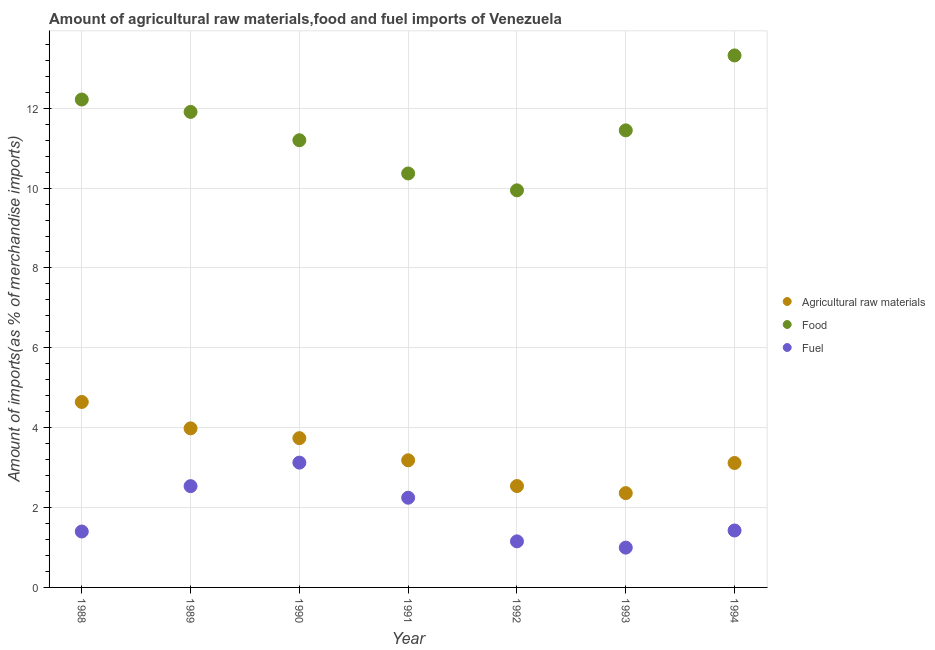How many different coloured dotlines are there?
Keep it short and to the point. 3. What is the percentage of food imports in 1993?
Your answer should be very brief. 11.45. Across all years, what is the maximum percentage of raw materials imports?
Ensure brevity in your answer.  4.64. Across all years, what is the minimum percentage of raw materials imports?
Ensure brevity in your answer.  2.36. In which year was the percentage of fuel imports minimum?
Make the answer very short. 1993. What is the total percentage of raw materials imports in the graph?
Your answer should be compact. 23.57. What is the difference between the percentage of food imports in 1991 and that in 1994?
Ensure brevity in your answer.  -2.96. What is the difference between the percentage of food imports in 1988 and the percentage of fuel imports in 1993?
Provide a short and direct response. 11.22. What is the average percentage of fuel imports per year?
Your answer should be compact. 1.84. In the year 1990, what is the difference between the percentage of fuel imports and percentage of food imports?
Your answer should be compact. -8.07. What is the ratio of the percentage of fuel imports in 1990 to that in 1991?
Provide a short and direct response. 1.39. Is the percentage of raw materials imports in 1989 less than that in 1992?
Keep it short and to the point. No. Is the difference between the percentage of fuel imports in 1991 and 1994 greater than the difference between the percentage of food imports in 1991 and 1994?
Provide a short and direct response. Yes. What is the difference between the highest and the second highest percentage of food imports?
Provide a succinct answer. 1.1. What is the difference between the highest and the lowest percentage of raw materials imports?
Your answer should be very brief. 2.28. Is the sum of the percentage of fuel imports in 1988 and 1992 greater than the maximum percentage of raw materials imports across all years?
Ensure brevity in your answer.  No. Is it the case that in every year, the sum of the percentage of raw materials imports and percentage of food imports is greater than the percentage of fuel imports?
Your answer should be very brief. Yes. Does the percentage of food imports monotonically increase over the years?
Provide a short and direct response. No. Is the percentage of food imports strictly less than the percentage of fuel imports over the years?
Provide a short and direct response. No. How many dotlines are there?
Your answer should be very brief. 3. How many years are there in the graph?
Keep it short and to the point. 7. What is the difference between two consecutive major ticks on the Y-axis?
Keep it short and to the point. 2. Does the graph contain any zero values?
Give a very brief answer. No. Where does the legend appear in the graph?
Your answer should be very brief. Center right. How are the legend labels stacked?
Provide a succinct answer. Vertical. What is the title of the graph?
Your answer should be compact. Amount of agricultural raw materials,food and fuel imports of Venezuela. What is the label or title of the Y-axis?
Your answer should be very brief. Amount of imports(as % of merchandise imports). What is the Amount of imports(as % of merchandise imports) in Agricultural raw materials in 1988?
Keep it short and to the point. 4.64. What is the Amount of imports(as % of merchandise imports) in Food in 1988?
Your answer should be very brief. 12.22. What is the Amount of imports(as % of merchandise imports) of Fuel in 1988?
Make the answer very short. 1.4. What is the Amount of imports(as % of merchandise imports) of Agricultural raw materials in 1989?
Your answer should be very brief. 3.98. What is the Amount of imports(as % of merchandise imports) in Food in 1989?
Your answer should be compact. 11.91. What is the Amount of imports(as % of merchandise imports) of Fuel in 1989?
Make the answer very short. 2.54. What is the Amount of imports(as % of merchandise imports) in Agricultural raw materials in 1990?
Provide a succinct answer. 3.74. What is the Amount of imports(as % of merchandise imports) of Food in 1990?
Make the answer very short. 11.2. What is the Amount of imports(as % of merchandise imports) of Fuel in 1990?
Your response must be concise. 3.13. What is the Amount of imports(as % of merchandise imports) in Agricultural raw materials in 1991?
Provide a succinct answer. 3.18. What is the Amount of imports(as % of merchandise imports) of Food in 1991?
Make the answer very short. 10.37. What is the Amount of imports(as % of merchandise imports) in Fuel in 1991?
Make the answer very short. 2.25. What is the Amount of imports(as % of merchandise imports) in Agricultural raw materials in 1992?
Make the answer very short. 2.54. What is the Amount of imports(as % of merchandise imports) in Food in 1992?
Your answer should be compact. 9.94. What is the Amount of imports(as % of merchandise imports) in Fuel in 1992?
Provide a succinct answer. 1.15. What is the Amount of imports(as % of merchandise imports) of Agricultural raw materials in 1993?
Keep it short and to the point. 2.36. What is the Amount of imports(as % of merchandise imports) in Food in 1993?
Provide a succinct answer. 11.45. What is the Amount of imports(as % of merchandise imports) in Fuel in 1993?
Make the answer very short. 1. What is the Amount of imports(as % of merchandise imports) in Agricultural raw materials in 1994?
Give a very brief answer. 3.12. What is the Amount of imports(as % of merchandise imports) of Food in 1994?
Provide a short and direct response. 13.32. What is the Amount of imports(as % of merchandise imports) of Fuel in 1994?
Ensure brevity in your answer.  1.43. Across all years, what is the maximum Amount of imports(as % of merchandise imports) of Agricultural raw materials?
Ensure brevity in your answer.  4.64. Across all years, what is the maximum Amount of imports(as % of merchandise imports) of Food?
Your answer should be very brief. 13.32. Across all years, what is the maximum Amount of imports(as % of merchandise imports) in Fuel?
Provide a succinct answer. 3.13. Across all years, what is the minimum Amount of imports(as % of merchandise imports) of Agricultural raw materials?
Make the answer very short. 2.36. Across all years, what is the minimum Amount of imports(as % of merchandise imports) of Food?
Provide a short and direct response. 9.94. Across all years, what is the minimum Amount of imports(as % of merchandise imports) of Fuel?
Provide a short and direct response. 1. What is the total Amount of imports(as % of merchandise imports) in Agricultural raw materials in the graph?
Make the answer very short. 23.57. What is the total Amount of imports(as % of merchandise imports) in Food in the graph?
Provide a succinct answer. 80.4. What is the total Amount of imports(as % of merchandise imports) in Fuel in the graph?
Your answer should be very brief. 12.88. What is the difference between the Amount of imports(as % of merchandise imports) in Agricultural raw materials in 1988 and that in 1989?
Make the answer very short. 0.66. What is the difference between the Amount of imports(as % of merchandise imports) in Food in 1988 and that in 1989?
Offer a very short reply. 0.31. What is the difference between the Amount of imports(as % of merchandise imports) in Fuel in 1988 and that in 1989?
Ensure brevity in your answer.  -1.14. What is the difference between the Amount of imports(as % of merchandise imports) of Agricultural raw materials in 1988 and that in 1990?
Provide a short and direct response. 0.91. What is the difference between the Amount of imports(as % of merchandise imports) in Food in 1988 and that in 1990?
Your answer should be compact. 1.02. What is the difference between the Amount of imports(as % of merchandise imports) of Fuel in 1988 and that in 1990?
Keep it short and to the point. -1.72. What is the difference between the Amount of imports(as % of merchandise imports) in Agricultural raw materials in 1988 and that in 1991?
Your answer should be compact. 1.46. What is the difference between the Amount of imports(as % of merchandise imports) of Food in 1988 and that in 1991?
Keep it short and to the point. 1.85. What is the difference between the Amount of imports(as % of merchandise imports) of Fuel in 1988 and that in 1991?
Your answer should be compact. -0.85. What is the difference between the Amount of imports(as % of merchandise imports) of Agricultural raw materials in 1988 and that in 1992?
Your response must be concise. 2.11. What is the difference between the Amount of imports(as % of merchandise imports) in Food in 1988 and that in 1992?
Offer a very short reply. 2.27. What is the difference between the Amount of imports(as % of merchandise imports) in Fuel in 1988 and that in 1992?
Provide a succinct answer. 0.25. What is the difference between the Amount of imports(as % of merchandise imports) in Agricultural raw materials in 1988 and that in 1993?
Offer a terse response. 2.28. What is the difference between the Amount of imports(as % of merchandise imports) of Food in 1988 and that in 1993?
Your answer should be very brief. 0.77. What is the difference between the Amount of imports(as % of merchandise imports) in Fuel in 1988 and that in 1993?
Make the answer very short. 0.4. What is the difference between the Amount of imports(as % of merchandise imports) in Agricultural raw materials in 1988 and that in 1994?
Provide a succinct answer. 1.53. What is the difference between the Amount of imports(as % of merchandise imports) in Food in 1988 and that in 1994?
Keep it short and to the point. -1.1. What is the difference between the Amount of imports(as % of merchandise imports) of Fuel in 1988 and that in 1994?
Keep it short and to the point. -0.03. What is the difference between the Amount of imports(as % of merchandise imports) in Agricultural raw materials in 1989 and that in 1990?
Your response must be concise. 0.25. What is the difference between the Amount of imports(as % of merchandise imports) in Food in 1989 and that in 1990?
Your answer should be compact. 0.71. What is the difference between the Amount of imports(as % of merchandise imports) of Fuel in 1989 and that in 1990?
Keep it short and to the point. -0.59. What is the difference between the Amount of imports(as % of merchandise imports) of Agricultural raw materials in 1989 and that in 1991?
Your answer should be very brief. 0.8. What is the difference between the Amount of imports(as % of merchandise imports) of Food in 1989 and that in 1991?
Your answer should be compact. 1.54. What is the difference between the Amount of imports(as % of merchandise imports) of Fuel in 1989 and that in 1991?
Make the answer very short. 0.29. What is the difference between the Amount of imports(as % of merchandise imports) in Agricultural raw materials in 1989 and that in 1992?
Offer a very short reply. 1.45. What is the difference between the Amount of imports(as % of merchandise imports) of Food in 1989 and that in 1992?
Your answer should be compact. 1.96. What is the difference between the Amount of imports(as % of merchandise imports) of Fuel in 1989 and that in 1992?
Your response must be concise. 1.38. What is the difference between the Amount of imports(as % of merchandise imports) in Agricultural raw materials in 1989 and that in 1993?
Offer a terse response. 1.62. What is the difference between the Amount of imports(as % of merchandise imports) of Food in 1989 and that in 1993?
Your answer should be compact. 0.46. What is the difference between the Amount of imports(as % of merchandise imports) of Fuel in 1989 and that in 1993?
Your answer should be compact. 1.54. What is the difference between the Amount of imports(as % of merchandise imports) in Agricultural raw materials in 1989 and that in 1994?
Offer a very short reply. 0.87. What is the difference between the Amount of imports(as % of merchandise imports) of Food in 1989 and that in 1994?
Provide a short and direct response. -1.41. What is the difference between the Amount of imports(as % of merchandise imports) in Fuel in 1989 and that in 1994?
Make the answer very short. 1.11. What is the difference between the Amount of imports(as % of merchandise imports) in Agricultural raw materials in 1990 and that in 1991?
Your response must be concise. 0.55. What is the difference between the Amount of imports(as % of merchandise imports) in Food in 1990 and that in 1991?
Your answer should be compact. 0.83. What is the difference between the Amount of imports(as % of merchandise imports) of Fuel in 1990 and that in 1991?
Offer a very short reply. 0.88. What is the difference between the Amount of imports(as % of merchandise imports) in Agricultural raw materials in 1990 and that in 1992?
Provide a succinct answer. 1.2. What is the difference between the Amount of imports(as % of merchandise imports) in Food in 1990 and that in 1992?
Your answer should be very brief. 1.25. What is the difference between the Amount of imports(as % of merchandise imports) in Fuel in 1990 and that in 1992?
Your answer should be compact. 1.97. What is the difference between the Amount of imports(as % of merchandise imports) of Agricultural raw materials in 1990 and that in 1993?
Make the answer very short. 1.38. What is the difference between the Amount of imports(as % of merchandise imports) in Food in 1990 and that in 1993?
Make the answer very short. -0.25. What is the difference between the Amount of imports(as % of merchandise imports) of Fuel in 1990 and that in 1993?
Offer a terse response. 2.13. What is the difference between the Amount of imports(as % of merchandise imports) in Agricultural raw materials in 1990 and that in 1994?
Your answer should be compact. 0.62. What is the difference between the Amount of imports(as % of merchandise imports) of Food in 1990 and that in 1994?
Make the answer very short. -2.12. What is the difference between the Amount of imports(as % of merchandise imports) in Fuel in 1990 and that in 1994?
Offer a very short reply. 1.7. What is the difference between the Amount of imports(as % of merchandise imports) of Agricultural raw materials in 1991 and that in 1992?
Ensure brevity in your answer.  0.65. What is the difference between the Amount of imports(as % of merchandise imports) of Food in 1991 and that in 1992?
Provide a short and direct response. 0.42. What is the difference between the Amount of imports(as % of merchandise imports) of Fuel in 1991 and that in 1992?
Give a very brief answer. 1.09. What is the difference between the Amount of imports(as % of merchandise imports) in Agricultural raw materials in 1991 and that in 1993?
Give a very brief answer. 0.82. What is the difference between the Amount of imports(as % of merchandise imports) in Food in 1991 and that in 1993?
Make the answer very short. -1.08. What is the difference between the Amount of imports(as % of merchandise imports) in Fuel in 1991 and that in 1993?
Ensure brevity in your answer.  1.25. What is the difference between the Amount of imports(as % of merchandise imports) in Agricultural raw materials in 1991 and that in 1994?
Offer a terse response. 0.07. What is the difference between the Amount of imports(as % of merchandise imports) of Food in 1991 and that in 1994?
Your response must be concise. -2.96. What is the difference between the Amount of imports(as % of merchandise imports) in Fuel in 1991 and that in 1994?
Offer a terse response. 0.82. What is the difference between the Amount of imports(as % of merchandise imports) in Agricultural raw materials in 1992 and that in 1993?
Your response must be concise. 0.18. What is the difference between the Amount of imports(as % of merchandise imports) in Food in 1992 and that in 1993?
Offer a terse response. -1.5. What is the difference between the Amount of imports(as % of merchandise imports) of Fuel in 1992 and that in 1993?
Your answer should be compact. 0.16. What is the difference between the Amount of imports(as % of merchandise imports) in Agricultural raw materials in 1992 and that in 1994?
Make the answer very short. -0.58. What is the difference between the Amount of imports(as % of merchandise imports) of Food in 1992 and that in 1994?
Offer a very short reply. -3.38. What is the difference between the Amount of imports(as % of merchandise imports) in Fuel in 1992 and that in 1994?
Provide a short and direct response. -0.27. What is the difference between the Amount of imports(as % of merchandise imports) in Agricultural raw materials in 1993 and that in 1994?
Offer a terse response. -0.75. What is the difference between the Amount of imports(as % of merchandise imports) in Food in 1993 and that in 1994?
Provide a succinct answer. -1.88. What is the difference between the Amount of imports(as % of merchandise imports) in Fuel in 1993 and that in 1994?
Keep it short and to the point. -0.43. What is the difference between the Amount of imports(as % of merchandise imports) of Agricultural raw materials in 1988 and the Amount of imports(as % of merchandise imports) of Food in 1989?
Your answer should be compact. -7.26. What is the difference between the Amount of imports(as % of merchandise imports) in Agricultural raw materials in 1988 and the Amount of imports(as % of merchandise imports) in Fuel in 1989?
Give a very brief answer. 2.11. What is the difference between the Amount of imports(as % of merchandise imports) in Food in 1988 and the Amount of imports(as % of merchandise imports) in Fuel in 1989?
Offer a very short reply. 9.68. What is the difference between the Amount of imports(as % of merchandise imports) of Agricultural raw materials in 1988 and the Amount of imports(as % of merchandise imports) of Food in 1990?
Your answer should be compact. -6.55. What is the difference between the Amount of imports(as % of merchandise imports) of Agricultural raw materials in 1988 and the Amount of imports(as % of merchandise imports) of Fuel in 1990?
Give a very brief answer. 1.52. What is the difference between the Amount of imports(as % of merchandise imports) of Food in 1988 and the Amount of imports(as % of merchandise imports) of Fuel in 1990?
Make the answer very short. 9.09. What is the difference between the Amount of imports(as % of merchandise imports) of Agricultural raw materials in 1988 and the Amount of imports(as % of merchandise imports) of Food in 1991?
Your response must be concise. -5.72. What is the difference between the Amount of imports(as % of merchandise imports) of Agricultural raw materials in 1988 and the Amount of imports(as % of merchandise imports) of Fuel in 1991?
Make the answer very short. 2.4. What is the difference between the Amount of imports(as % of merchandise imports) of Food in 1988 and the Amount of imports(as % of merchandise imports) of Fuel in 1991?
Offer a very short reply. 9.97. What is the difference between the Amount of imports(as % of merchandise imports) of Agricultural raw materials in 1988 and the Amount of imports(as % of merchandise imports) of Fuel in 1992?
Give a very brief answer. 3.49. What is the difference between the Amount of imports(as % of merchandise imports) in Food in 1988 and the Amount of imports(as % of merchandise imports) in Fuel in 1992?
Offer a very short reply. 11.06. What is the difference between the Amount of imports(as % of merchandise imports) of Agricultural raw materials in 1988 and the Amount of imports(as % of merchandise imports) of Food in 1993?
Your answer should be compact. -6.8. What is the difference between the Amount of imports(as % of merchandise imports) in Agricultural raw materials in 1988 and the Amount of imports(as % of merchandise imports) in Fuel in 1993?
Your answer should be compact. 3.65. What is the difference between the Amount of imports(as % of merchandise imports) of Food in 1988 and the Amount of imports(as % of merchandise imports) of Fuel in 1993?
Provide a short and direct response. 11.22. What is the difference between the Amount of imports(as % of merchandise imports) of Agricultural raw materials in 1988 and the Amount of imports(as % of merchandise imports) of Food in 1994?
Offer a very short reply. -8.68. What is the difference between the Amount of imports(as % of merchandise imports) of Agricultural raw materials in 1988 and the Amount of imports(as % of merchandise imports) of Fuel in 1994?
Your response must be concise. 3.22. What is the difference between the Amount of imports(as % of merchandise imports) in Food in 1988 and the Amount of imports(as % of merchandise imports) in Fuel in 1994?
Give a very brief answer. 10.79. What is the difference between the Amount of imports(as % of merchandise imports) in Agricultural raw materials in 1989 and the Amount of imports(as % of merchandise imports) in Food in 1990?
Ensure brevity in your answer.  -7.21. What is the difference between the Amount of imports(as % of merchandise imports) of Agricultural raw materials in 1989 and the Amount of imports(as % of merchandise imports) of Fuel in 1990?
Your answer should be compact. 0.86. What is the difference between the Amount of imports(as % of merchandise imports) in Food in 1989 and the Amount of imports(as % of merchandise imports) in Fuel in 1990?
Give a very brief answer. 8.78. What is the difference between the Amount of imports(as % of merchandise imports) of Agricultural raw materials in 1989 and the Amount of imports(as % of merchandise imports) of Food in 1991?
Ensure brevity in your answer.  -6.38. What is the difference between the Amount of imports(as % of merchandise imports) in Agricultural raw materials in 1989 and the Amount of imports(as % of merchandise imports) in Fuel in 1991?
Provide a succinct answer. 1.74. What is the difference between the Amount of imports(as % of merchandise imports) of Food in 1989 and the Amount of imports(as % of merchandise imports) of Fuel in 1991?
Ensure brevity in your answer.  9.66. What is the difference between the Amount of imports(as % of merchandise imports) of Agricultural raw materials in 1989 and the Amount of imports(as % of merchandise imports) of Food in 1992?
Give a very brief answer. -5.96. What is the difference between the Amount of imports(as % of merchandise imports) in Agricultural raw materials in 1989 and the Amount of imports(as % of merchandise imports) in Fuel in 1992?
Ensure brevity in your answer.  2.83. What is the difference between the Amount of imports(as % of merchandise imports) in Food in 1989 and the Amount of imports(as % of merchandise imports) in Fuel in 1992?
Your answer should be compact. 10.75. What is the difference between the Amount of imports(as % of merchandise imports) of Agricultural raw materials in 1989 and the Amount of imports(as % of merchandise imports) of Food in 1993?
Make the answer very short. -7.46. What is the difference between the Amount of imports(as % of merchandise imports) in Agricultural raw materials in 1989 and the Amount of imports(as % of merchandise imports) in Fuel in 1993?
Provide a succinct answer. 2.99. What is the difference between the Amount of imports(as % of merchandise imports) in Food in 1989 and the Amount of imports(as % of merchandise imports) in Fuel in 1993?
Give a very brief answer. 10.91. What is the difference between the Amount of imports(as % of merchandise imports) of Agricultural raw materials in 1989 and the Amount of imports(as % of merchandise imports) of Food in 1994?
Keep it short and to the point. -9.34. What is the difference between the Amount of imports(as % of merchandise imports) in Agricultural raw materials in 1989 and the Amount of imports(as % of merchandise imports) in Fuel in 1994?
Give a very brief answer. 2.56. What is the difference between the Amount of imports(as % of merchandise imports) in Food in 1989 and the Amount of imports(as % of merchandise imports) in Fuel in 1994?
Make the answer very short. 10.48. What is the difference between the Amount of imports(as % of merchandise imports) in Agricultural raw materials in 1990 and the Amount of imports(as % of merchandise imports) in Food in 1991?
Keep it short and to the point. -6.63. What is the difference between the Amount of imports(as % of merchandise imports) in Agricultural raw materials in 1990 and the Amount of imports(as % of merchandise imports) in Fuel in 1991?
Your response must be concise. 1.49. What is the difference between the Amount of imports(as % of merchandise imports) of Food in 1990 and the Amount of imports(as % of merchandise imports) of Fuel in 1991?
Your answer should be compact. 8.95. What is the difference between the Amount of imports(as % of merchandise imports) of Agricultural raw materials in 1990 and the Amount of imports(as % of merchandise imports) of Food in 1992?
Keep it short and to the point. -6.21. What is the difference between the Amount of imports(as % of merchandise imports) of Agricultural raw materials in 1990 and the Amount of imports(as % of merchandise imports) of Fuel in 1992?
Your answer should be very brief. 2.58. What is the difference between the Amount of imports(as % of merchandise imports) in Food in 1990 and the Amount of imports(as % of merchandise imports) in Fuel in 1992?
Offer a very short reply. 10.04. What is the difference between the Amount of imports(as % of merchandise imports) in Agricultural raw materials in 1990 and the Amount of imports(as % of merchandise imports) in Food in 1993?
Make the answer very short. -7.71. What is the difference between the Amount of imports(as % of merchandise imports) in Agricultural raw materials in 1990 and the Amount of imports(as % of merchandise imports) in Fuel in 1993?
Make the answer very short. 2.74. What is the difference between the Amount of imports(as % of merchandise imports) in Food in 1990 and the Amount of imports(as % of merchandise imports) in Fuel in 1993?
Keep it short and to the point. 10.2. What is the difference between the Amount of imports(as % of merchandise imports) in Agricultural raw materials in 1990 and the Amount of imports(as % of merchandise imports) in Food in 1994?
Provide a short and direct response. -9.58. What is the difference between the Amount of imports(as % of merchandise imports) in Agricultural raw materials in 1990 and the Amount of imports(as % of merchandise imports) in Fuel in 1994?
Offer a very short reply. 2.31. What is the difference between the Amount of imports(as % of merchandise imports) in Food in 1990 and the Amount of imports(as % of merchandise imports) in Fuel in 1994?
Make the answer very short. 9.77. What is the difference between the Amount of imports(as % of merchandise imports) of Agricultural raw materials in 1991 and the Amount of imports(as % of merchandise imports) of Food in 1992?
Your answer should be very brief. -6.76. What is the difference between the Amount of imports(as % of merchandise imports) in Agricultural raw materials in 1991 and the Amount of imports(as % of merchandise imports) in Fuel in 1992?
Provide a short and direct response. 2.03. What is the difference between the Amount of imports(as % of merchandise imports) of Food in 1991 and the Amount of imports(as % of merchandise imports) of Fuel in 1992?
Make the answer very short. 9.21. What is the difference between the Amount of imports(as % of merchandise imports) of Agricultural raw materials in 1991 and the Amount of imports(as % of merchandise imports) of Food in 1993?
Give a very brief answer. -8.26. What is the difference between the Amount of imports(as % of merchandise imports) in Agricultural raw materials in 1991 and the Amount of imports(as % of merchandise imports) in Fuel in 1993?
Your answer should be very brief. 2.19. What is the difference between the Amount of imports(as % of merchandise imports) of Food in 1991 and the Amount of imports(as % of merchandise imports) of Fuel in 1993?
Your response must be concise. 9.37. What is the difference between the Amount of imports(as % of merchandise imports) in Agricultural raw materials in 1991 and the Amount of imports(as % of merchandise imports) in Food in 1994?
Offer a terse response. -10.14. What is the difference between the Amount of imports(as % of merchandise imports) of Agricultural raw materials in 1991 and the Amount of imports(as % of merchandise imports) of Fuel in 1994?
Your answer should be very brief. 1.76. What is the difference between the Amount of imports(as % of merchandise imports) in Food in 1991 and the Amount of imports(as % of merchandise imports) in Fuel in 1994?
Offer a very short reply. 8.94. What is the difference between the Amount of imports(as % of merchandise imports) of Agricultural raw materials in 1992 and the Amount of imports(as % of merchandise imports) of Food in 1993?
Offer a terse response. -8.91. What is the difference between the Amount of imports(as % of merchandise imports) in Agricultural raw materials in 1992 and the Amount of imports(as % of merchandise imports) in Fuel in 1993?
Offer a terse response. 1.54. What is the difference between the Amount of imports(as % of merchandise imports) in Food in 1992 and the Amount of imports(as % of merchandise imports) in Fuel in 1993?
Keep it short and to the point. 8.95. What is the difference between the Amount of imports(as % of merchandise imports) of Agricultural raw materials in 1992 and the Amount of imports(as % of merchandise imports) of Food in 1994?
Ensure brevity in your answer.  -10.78. What is the difference between the Amount of imports(as % of merchandise imports) of Agricultural raw materials in 1992 and the Amount of imports(as % of merchandise imports) of Fuel in 1994?
Your response must be concise. 1.11. What is the difference between the Amount of imports(as % of merchandise imports) of Food in 1992 and the Amount of imports(as % of merchandise imports) of Fuel in 1994?
Your answer should be very brief. 8.52. What is the difference between the Amount of imports(as % of merchandise imports) in Agricultural raw materials in 1993 and the Amount of imports(as % of merchandise imports) in Food in 1994?
Offer a terse response. -10.96. What is the difference between the Amount of imports(as % of merchandise imports) in Agricultural raw materials in 1993 and the Amount of imports(as % of merchandise imports) in Fuel in 1994?
Provide a succinct answer. 0.94. What is the difference between the Amount of imports(as % of merchandise imports) of Food in 1993 and the Amount of imports(as % of merchandise imports) of Fuel in 1994?
Your response must be concise. 10.02. What is the average Amount of imports(as % of merchandise imports) of Agricultural raw materials per year?
Provide a succinct answer. 3.37. What is the average Amount of imports(as % of merchandise imports) of Food per year?
Make the answer very short. 11.49. What is the average Amount of imports(as % of merchandise imports) of Fuel per year?
Offer a very short reply. 1.84. In the year 1988, what is the difference between the Amount of imports(as % of merchandise imports) in Agricultural raw materials and Amount of imports(as % of merchandise imports) in Food?
Provide a short and direct response. -7.57. In the year 1988, what is the difference between the Amount of imports(as % of merchandise imports) in Agricultural raw materials and Amount of imports(as % of merchandise imports) in Fuel?
Give a very brief answer. 3.24. In the year 1988, what is the difference between the Amount of imports(as % of merchandise imports) in Food and Amount of imports(as % of merchandise imports) in Fuel?
Ensure brevity in your answer.  10.82. In the year 1989, what is the difference between the Amount of imports(as % of merchandise imports) of Agricultural raw materials and Amount of imports(as % of merchandise imports) of Food?
Provide a short and direct response. -7.92. In the year 1989, what is the difference between the Amount of imports(as % of merchandise imports) in Agricultural raw materials and Amount of imports(as % of merchandise imports) in Fuel?
Ensure brevity in your answer.  1.45. In the year 1989, what is the difference between the Amount of imports(as % of merchandise imports) of Food and Amount of imports(as % of merchandise imports) of Fuel?
Offer a terse response. 9.37. In the year 1990, what is the difference between the Amount of imports(as % of merchandise imports) of Agricultural raw materials and Amount of imports(as % of merchandise imports) of Food?
Ensure brevity in your answer.  -7.46. In the year 1990, what is the difference between the Amount of imports(as % of merchandise imports) in Agricultural raw materials and Amount of imports(as % of merchandise imports) in Fuel?
Your response must be concise. 0.61. In the year 1990, what is the difference between the Amount of imports(as % of merchandise imports) of Food and Amount of imports(as % of merchandise imports) of Fuel?
Ensure brevity in your answer.  8.07. In the year 1991, what is the difference between the Amount of imports(as % of merchandise imports) in Agricultural raw materials and Amount of imports(as % of merchandise imports) in Food?
Your answer should be very brief. -7.18. In the year 1991, what is the difference between the Amount of imports(as % of merchandise imports) of Agricultural raw materials and Amount of imports(as % of merchandise imports) of Fuel?
Your answer should be very brief. 0.94. In the year 1991, what is the difference between the Amount of imports(as % of merchandise imports) in Food and Amount of imports(as % of merchandise imports) in Fuel?
Make the answer very short. 8.12. In the year 1992, what is the difference between the Amount of imports(as % of merchandise imports) in Agricultural raw materials and Amount of imports(as % of merchandise imports) in Food?
Your response must be concise. -7.41. In the year 1992, what is the difference between the Amount of imports(as % of merchandise imports) of Agricultural raw materials and Amount of imports(as % of merchandise imports) of Fuel?
Your response must be concise. 1.39. In the year 1992, what is the difference between the Amount of imports(as % of merchandise imports) in Food and Amount of imports(as % of merchandise imports) in Fuel?
Provide a short and direct response. 8.79. In the year 1993, what is the difference between the Amount of imports(as % of merchandise imports) of Agricultural raw materials and Amount of imports(as % of merchandise imports) of Food?
Offer a very short reply. -9.08. In the year 1993, what is the difference between the Amount of imports(as % of merchandise imports) of Agricultural raw materials and Amount of imports(as % of merchandise imports) of Fuel?
Your response must be concise. 1.36. In the year 1993, what is the difference between the Amount of imports(as % of merchandise imports) in Food and Amount of imports(as % of merchandise imports) in Fuel?
Offer a terse response. 10.45. In the year 1994, what is the difference between the Amount of imports(as % of merchandise imports) in Agricultural raw materials and Amount of imports(as % of merchandise imports) in Food?
Make the answer very short. -10.21. In the year 1994, what is the difference between the Amount of imports(as % of merchandise imports) in Agricultural raw materials and Amount of imports(as % of merchandise imports) in Fuel?
Give a very brief answer. 1.69. In the year 1994, what is the difference between the Amount of imports(as % of merchandise imports) in Food and Amount of imports(as % of merchandise imports) in Fuel?
Offer a very short reply. 11.9. What is the ratio of the Amount of imports(as % of merchandise imports) of Agricultural raw materials in 1988 to that in 1989?
Ensure brevity in your answer.  1.17. What is the ratio of the Amount of imports(as % of merchandise imports) of Food in 1988 to that in 1989?
Make the answer very short. 1.03. What is the ratio of the Amount of imports(as % of merchandise imports) of Fuel in 1988 to that in 1989?
Your answer should be very brief. 0.55. What is the ratio of the Amount of imports(as % of merchandise imports) of Agricultural raw materials in 1988 to that in 1990?
Offer a terse response. 1.24. What is the ratio of the Amount of imports(as % of merchandise imports) of Food in 1988 to that in 1990?
Ensure brevity in your answer.  1.09. What is the ratio of the Amount of imports(as % of merchandise imports) in Fuel in 1988 to that in 1990?
Provide a succinct answer. 0.45. What is the ratio of the Amount of imports(as % of merchandise imports) in Agricultural raw materials in 1988 to that in 1991?
Keep it short and to the point. 1.46. What is the ratio of the Amount of imports(as % of merchandise imports) in Food in 1988 to that in 1991?
Offer a very short reply. 1.18. What is the ratio of the Amount of imports(as % of merchandise imports) of Fuel in 1988 to that in 1991?
Offer a very short reply. 0.62. What is the ratio of the Amount of imports(as % of merchandise imports) of Agricultural raw materials in 1988 to that in 1992?
Make the answer very short. 1.83. What is the ratio of the Amount of imports(as % of merchandise imports) in Food in 1988 to that in 1992?
Give a very brief answer. 1.23. What is the ratio of the Amount of imports(as % of merchandise imports) in Fuel in 1988 to that in 1992?
Provide a short and direct response. 1.21. What is the ratio of the Amount of imports(as % of merchandise imports) of Agricultural raw materials in 1988 to that in 1993?
Provide a short and direct response. 1.97. What is the ratio of the Amount of imports(as % of merchandise imports) in Food in 1988 to that in 1993?
Ensure brevity in your answer.  1.07. What is the ratio of the Amount of imports(as % of merchandise imports) in Fuel in 1988 to that in 1993?
Offer a very short reply. 1.41. What is the ratio of the Amount of imports(as % of merchandise imports) of Agricultural raw materials in 1988 to that in 1994?
Your answer should be very brief. 1.49. What is the ratio of the Amount of imports(as % of merchandise imports) in Food in 1988 to that in 1994?
Your response must be concise. 0.92. What is the ratio of the Amount of imports(as % of merchandise imports) in Fuel in 1988 to that in 1994?
Ensure brevity in your answer.  0.98. What is the ratio of the Amount of imports(as % of merchandise imports) of Agricultural raw materials in 1989 to that in 1990?
Provide a short and direct response. 1.07. What is the ratio of the Amount of imports(as % of merchandise imports) of Food in 1989 to that in 1990?
Your answer should be very brief. 1.06. What is the ratio of the Amount of imports(as % of merchandise imports) in Fuel in 1989 to that in 1990?
Give a very brief answer. 0.81. What is the ratio of the Amount of imports(as % of merchandise imports) of Agricultural raw materials in 1989 to that in 1991?
Your answer should be very brief. 1.25. What is the ratio of the Amount of imports(as % of merchandise imports) in Food in 1989 to that in 1991?
Provide a short and direct response. 1.15. What is the ratio of the Amount of imports(as % of merchandise imports) in Fuel in 1989 to that in 1991?
Keep it short and to the point. 1.13. What is the ratio of the Amount of imports(as % of merchandise imports) of Agricultural raw materials in 1989 to that in 1992?
Give a very brief answer. 1.57. What is the ratio of the Amount of imports(as % of merchandise imports) of Food in 1989 to that in 1992?
Provide a succinct answer. 1.2. What is the ratio of the Amount of imports(as % of merchandise imports) in Fuel in 1989 to that in 1992?
Your answer should be very brief. 2.2. What is the ratio of the Amount of imports(as % of merchandise imports) of Agricultural raw materials in 1989 to that in 1993?
Ensure brevity in your answer.  1.69. What is the ratio of the Amount of imports(as % of merchandise imports) in Food in 1989 to that in 1993?
Your answer should be compact. 1.04. What is the ratio of the Amount of imports(as % of merchandise imports) of Fuel in 1989 to that in 1993?
Offer a very short reply. 2.54. What is the ratio of the Amount of imports(as % of merchandise imports) of Agricultural raw materials in 1989 to that in 1994?
Offer a very short reply. 1.28. What is the ratio of the Amount of imports(as % of merchandise imports) of Food in 1989 to that in 1994?
Your response must be concise. 0.89. What is the ratio of the Amount of imports(as % of merchandise imports) of Fuel in 1989 to that in 1994?
Offer a very short reply. 1.78. What is the ratio of the Amount of imports(as % of merchandise imports) of Agricultural raw materials in 1990 to that in 1991?
Provide a succinct answer. 1.17. What is the ratio of the Amount of imports(as % of merchandise imports) of Food in 1990 to that in 1991?
Your response must be concise. 1.08. What is the ratio of the Amount of imports(as % of merchandise imports) of Fuel in 1990 to that in 1991?
Provide a succinct answer. 1.39. What is the ratio of the Amount of imports(as % of merchandise imports) in Agricultural raw materials in 1990 to that in 1992?
Offer a terse response. 1.47. What is the ratio of the Amount of imports(as % of merchandise imports) of Food in 1990 to that in 1992?
Offer a terse response. 1.13. What is the ratio of the Amount of imports(as % of merchandise imports) of Fuel in 1990 to that in 1992?
Offer a terse response. 2.71. What is the ratio of the Amount of imports(as % of merchandise imports) in Agricultural raw materials in 1990 to that in 1993?
Your answer should be compact. 1.58. What is the ratio of the Amount of imports(as % of merchandise imports) in Food in 1990 to that in 1993?
Provide a short and direct response. 0.98. What is the ratio of the Amount of imports(as % of merchandise imports) in Fuel in 1990 to that in 1993?
Your answer should be compact. 3.14. What is the ratio of the Amount of imports(as % of merchandise imports) in Agricultural raw materials in 1990 to that in 1994?
Your answer should be compact. 1.2. What is the ratio of the Amount of imports(as % of merchandise imports) in Food in 1990 to that in 1994?
Offer a terse response. 0.84. What is the ratio of the Amount of imports(as % of merchandise imports) in Fuel in 1990 to that in 1994?
Give a very brief answer. 2.19. What is the ratio of the Amount of imports(as % of merchandise imports) in Agricultural raw materials in 1991 to that in 1992?
Ensure brevity in your answer.  1.25. What is the ratio of the Amount of imports(as % of merchandise imports) of Food in 1991 to that in 1992?
Your response must be concise. 1.04. What is the ratio of the Amount of imports(as % of merchandise imports) of Fuel in 1991 to that in 1992?
Offer a very short reply. 1.95. What is the ratio of the Amount of imports(as % of merchandise imports) of Agricultural raw materials in 1991 to that in 1993?
Your answer should be very brief. 1.35. What is the ratio of the Amount of imports(as % of merchandise imports) of Food in 1991 to that in 1993?
Your answer should be very brief. 0.91. What is the ratio of the Amount of imports(as % of merchandise imports) in Fuel in 1991 to that in 1993?
Your answer should be compact. 2.25. What is the ratio of the Amount of imports(as % of merchandise imports) in Agricultural raw materials in 1991 to that in 1994?
Give a very brief answer. 1.02. What is the ratio of the Amount of imports(as % of merchandise imports) of Food in 1991 to that in 1994?
Provide a short and direct response. 0.78. What is the ratio of the Amount of imports(as % of merchandise imports) in Fuel in 1991 to that in 1994?
Your answer should be compact. 1.58. What is the ratio of the Amount of imports(as % of merchandise imports) in Agricultural raw materials in 1992 to that in 1993?
Keep it short and to the point. 1.08. What is the ratio of the Amount of imports(as % of merchandise imports) in Food in 1992 to that in 1993?
Your response must be concise. 0.87. What is the ratio of the Amount of imports(as % of merchandise imports) of Fuel in 1992 to that in 1993?
Provide a short and direct response. 1.16. What is the ratio of the Amount of imports(as % of merchandise imports) of Agricultural raw materials in 1992 to that in 1994?
Offer a very short reply. 0.81. What is the ratio of the Amount of imports(as % of merchandise imports) of Food in 1992 to that in 1994?
Your answer should be compact. 0.75. What is the ratio of the Amount of imports(as % of merchandise imports) of Fuel in 1992 to that in 1994?
Offer a terse response. 0.81. What is the ratio of the Amount of imports(as % of merchandise imports) in Agricultural raw materials in 1993 to that in 1994?
Your answer should be compact. 0.76. What is the ratio of the Amount of imports(as % of merchandise imports) of Food in 1993 to that in 1994?
Your answer should be compact. 0.86. What is the ratio of the Amount of imports(as % of merchandise imports) in Fuel in 1993 to that in 1994?
Provide a short and direct response. 0.7. What is the difference between the highest and the second highest Amount of imports(as % of merchandise imports) in Agricultural raw materials?
Provide a short and direct response. 0.66. What is the difference between the highest and the second highest Amount of imports(as % of merchandise imports) of Food?
Your answer should be very brief. 1.1. What is the difference between the highest and the second highest Amount of imports(as % of merchandise imports) of Fuel?
Your answer should be compact. 0.59. What is the difference between the highest and the lowest Amount of imports(as % of merchandise imports) in Agricultural raw materials?
Your answer should be compact. 2.28. What is the difference between the highest and the lowest Amount of imports(as % of merchandise imports) in Food?
Offer a terse response. 3.38. What is the difference between the highest and the lowest Amount of imports(as % of merchandise imports) of Fuel?
Your response must be concise. 2.13. 